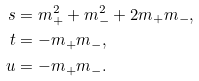<formula> <loc_0><loc_0><loc_500><loc_500>s & = m _ { + } ^ { 2 } + m _ { - } ^ { 2 } + 2 m _ { + } m _ { - } , \\ t & = - m _ { + } m _ { - } , \\ u & = - m _ { + } m _ { - } .</formula> 